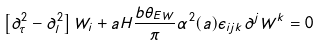<formula> <loc_0><loc_0><loc_500><loc_500>\left [ \partial ^ { 2 } _ { \tau } - \partial _ { l } ^ { 2 } \right ] W _ { i } + a H \frac { b \theta _ { E W } } { \pi } \alpha ^ { 2 } ( a ) \epsilon _ { i j k } \partial ^ { j } W ^ { k } = 0</formula> 